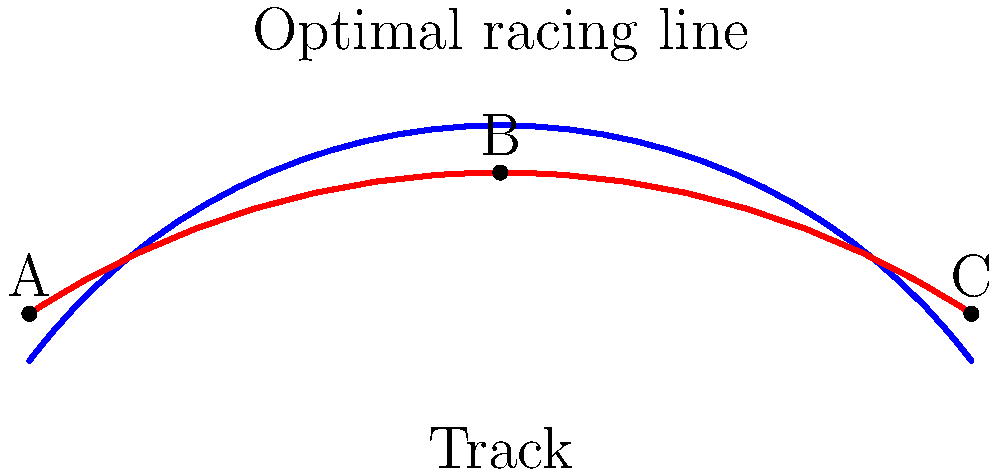In NASCAR truck racing, the optimal racing line through a banked turn can be modeled using a parabolic curve. Given that the racing line is represented by the equation $y = ax^2 + bx + c$, where $x$ is the distance along the track and $y$ is the lateral position, and it passes through the points A(0, 10), B(100, 40), and C(200, 10), calculate the coefficient $a$ of the quadratic term. Round your answer to four decimal places. To find the coefficient $a$ of the quadratic term, we'll follow these steps:

1) The general form of a quadratic equation is $y = ax^2 + bx + c$.

2) We have three points that the curve passes through:
   A(0, 10), B(100, 40), and C(200, 10)

3) Substituting these points into the equation:
   For A: $10 = a(0)^2 + b(0) + c$, so $c = 10$
   For B: $40 = a(100)^2 + b(100) + 10$
   For C: $10 = a(200)^2 + b(200) + 10$

4) Subtracting the equation for C from B:
   $30 = a(100)^2 + b(100) - [a(200)^2 + b(200)]$
   $30 = 10000a + 100b - 40000a - 200b$
   $30 = -30000a - 100b$

5) Simplifying:
   $30000a + 100b = -30$
   $300a + b = -0.3$ ... (Equation 1)

6) From the equation for C:
   $0 = a(200)^2 + b(200)$
   $0 = 40000a + 200b$
   $200b = -40000a$
   $b = -200a$ ... (Equation 2)

7) Substituting Equation 2 into Equation 1:
   $300a + (-200a) = -0.3$
   $100a = -0.3$
   $a = -0.003$

Therefore, the coefficient $a$ of the quadratic term is -0.0030.
Answer: -0.0030 